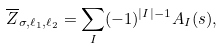<formula> <loc_0><loc_0><loc_500><loc_500>\overline { Z } _ { \sigma , \ell _ { 1 } , \ell _ { 2 } } = \sum _ { I } ( - 1 ) ^ { | I | - 1 } A _ { I } ( s ) ,</formula> 